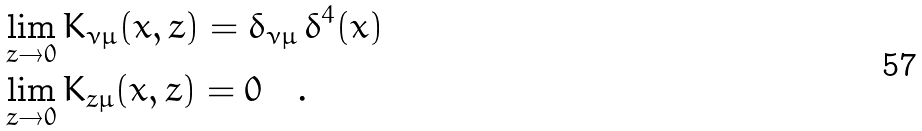Convert formula to latex. <formula><loc_0><loc_0><loc_500><loc_500>& \lim _ { z \to 0 } K _ { \nu \mu } ( x , z ) = \delta _ { \nu \mu } \, \delta ^ { 4 } ( x ) \\ & \lim _ { z \to 0 } K _ { z \mu } ( x , z ) = 0 \quad .</formula> 